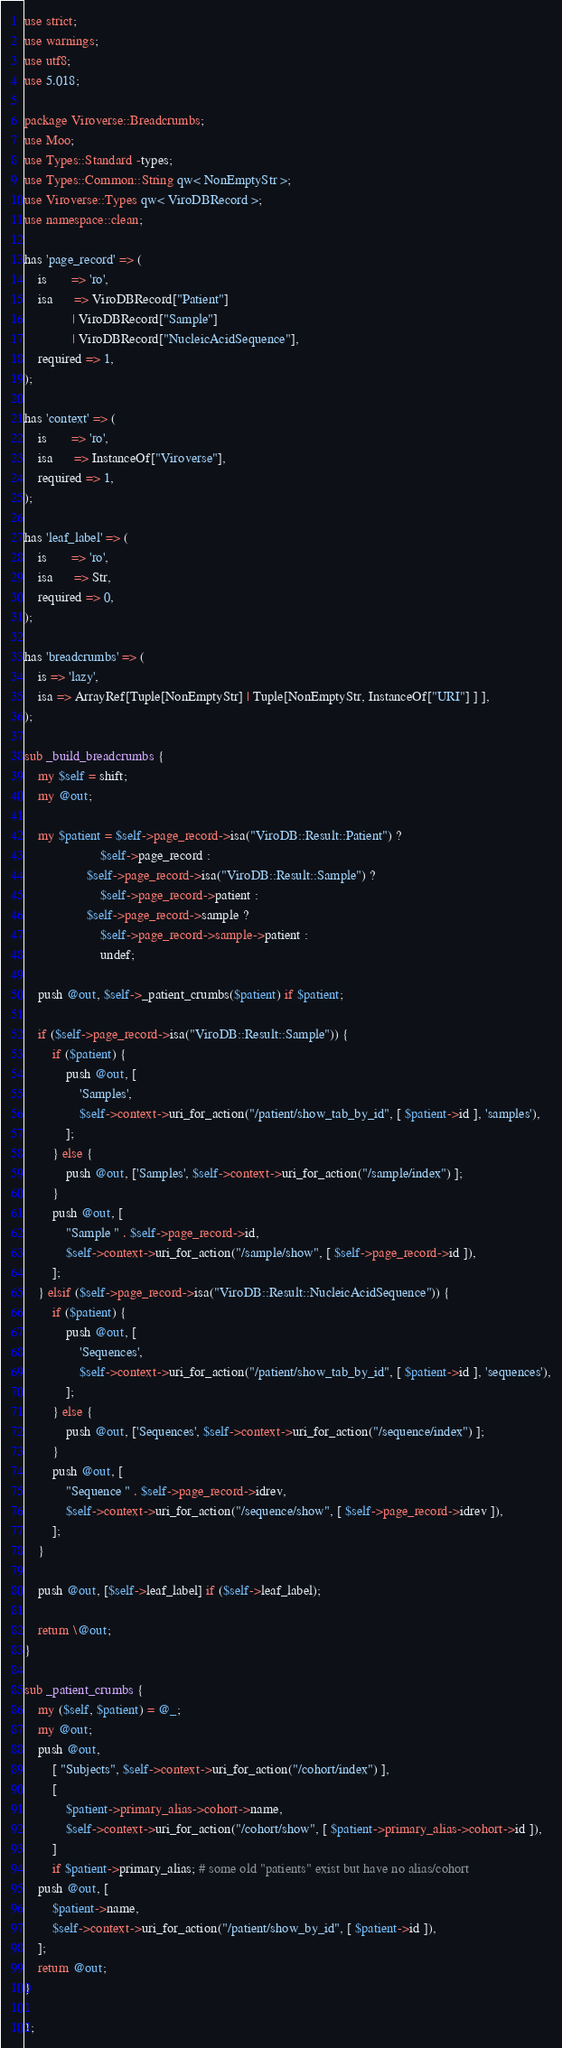Convert code to text. <code><loc_0><loc_0><loc_500><loc_500><_Perl_>use strict;
use warnings;
use utf8;
use 5.018;

package Viroverse::Breadcrumbs;
use Moo;
use Types::Standard -types;
use Types::Common::String qw< NonEmptyStr >;
use Viroverse::Types qw< ViroDBRecord >;
use namespace::clean;

has 'page_record' => (
    is       => 'ro',
    isa      => ViroDBRecord["Patient"]
              | ViroDBRecord["Sample"]
              | ViroDBRecord["NucleicAcidSequence"],
    required => 1,
);

has 'context' => (
    is       => 'ro',
    isa      => InstanceOf["Viroverse"],
    required => 1,
);

has 'leaf_label' => (
    is       => 'ro',
    isa      => Str,
    required => 0,
);

has 'breadcrumbs' => (
    is => 'lazy',
    isa => ArrayRef[Tuple[NonEmptyStr] | Tuple[NonEmptyStr, InstanceOf["URI"] ] ],
);

sub _build_breadcrumbs {
    my $self = shift;
    my @out;

    my $patient = $self->page_record->isa("ViroDB::Result::Patient") ?
                      $self->page_record :
                  $self->page_record->isa("ViroDB::Result::Sample") ?
                      $self->page_record->patient :
                  $self->page_record->sample ?
                      $self->page_record->sample->patient :
                      undef;

    push @out, $self->_patient_crumbs($patient) if $patient;

    if ($self->page_record->isa("ViroDB::Result::Sample")) {
        if ($patient) {
            push @out, [
                'Samples',
                $self->context->uri_for_action("/patient/show_tab_by_id", [ $patient->id ], 'samples'),
            ];
        } else {
            push @out, ['Samples', $self->context->uri_for_action("/sample/index") ];
        }
        push @out, [
            "Sample " . $self->page_record->id,
            $self->context->uri_for_action("/sample/show", [ $self->page_record->id ]),
        ];
    } elsif ($self->page_record->isa("ViroDB::Result::NucleicAcidSequence")) {
        if ($patient) {
            push @out, [
                'Sequences',
                $self->context->uri_for_action("/patient/show_tab_by_id", [ $patient->id ], 'sequences'),
            ];
        } else {
            push @out, ['Sequences', $self->context->uri_for_action("/sequence/index") ];
        }
        push @out, [
            "Sequence " . $self->page_record->idrev,
            $self->context->uri_for_action("/sequence/show", [ $self->page_record->idrev ]),
        ];
    }

    push @out, [$self->leaf_label] if ($self->leaf_label);

    return \@out;
}

sub _patient_crumbs {
    my ($self, $patient) = @_;
    my @out;
    push @out,
        [ "Subjects", $self->context->uri_for_action("/cohort/index") ],
        [
            $patient->primary_alias->cohort->name,
            $self->context->uri_for_action("/cohort/show", [ $patient->primary_alias->cohort->id ]),
        ]
        if $patient->primary_alias; # some old "patients" exist but have no alias/cohort
    push @out, [
        $patient->name,
        $self->context->uri_for_action("/patient/show_by_id", [ $patient->id ]),
    ];
    return @out;
}

1;
</code> 